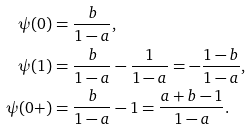<formula> <loc_0><loc_0><loc_500><loc_500>\psi ( 0 ) & = \frac { b } { 1 - a } , \\ \psi ( 1 ) & = \frac { b } { 1 - a } - \frac { 1 } { 1 - a } = - \frac { 1 - b } { 1 - a } , \\ \psi ( 0 + ) & = \frac { b } { 1 - a } - 1 = \frac { a + b - 1 } { 1 - a } .</formula> 